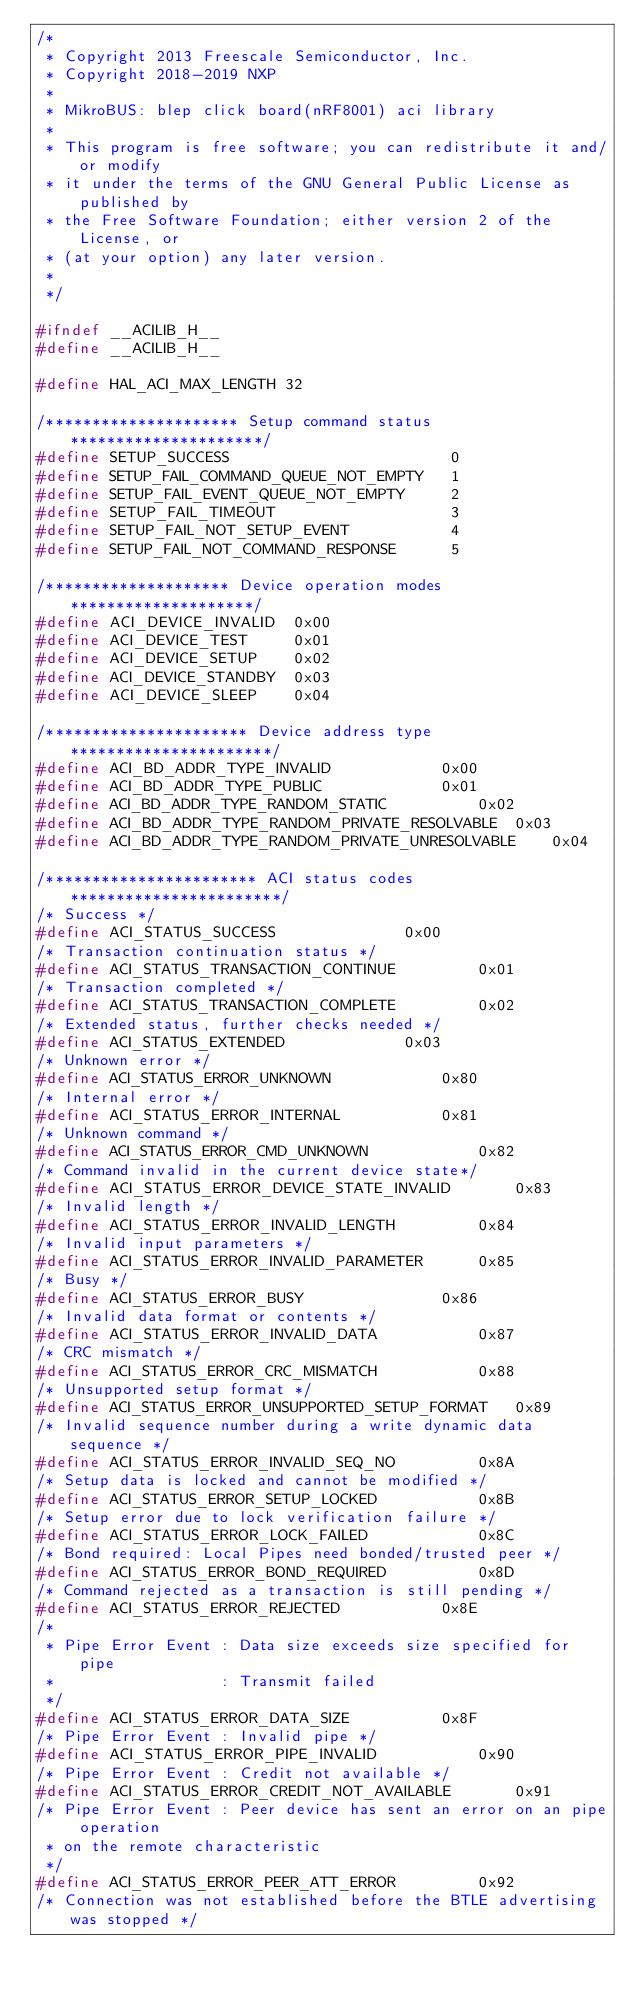Convert code to text. <code><loc_0><loc_0><loc_500><loc_500><_C_>/*
 * Copyright 2013 Freescale Semiconductor, Inc.
 * Copyright 2018-2019 NXP
 *
 * MikroBUS: blep click board(nRF8001) aci library
 *
 * This program is free software; you can redistribute it and/or modify
 * it under the terms of the GNU General Public License as published by
 * the Free Software Foundation; either version 2 of the License, or
 * (at your option) any later version.
 *
 */

#ifndef __ACILIB_H__
#define __ACILIB_H__

#define HAL_ACI_MAX_LENGTH 32

/********************* Setup command status *********************/
#define SETUP_SUCCESS                        0
#define SETUP_FAIL_COMMAND_QUEUE_NOT_EMPTY   1
#define SETUP_FAIL_EVENT_QUEUE_NOT_EMPTY     2
#define SETUP_FAIL_TIMEOUT                   3
#define SETUP_FAIL_NOT_SETUP_EVENT           4
#define SETUP_FAIL_NOT_COMMAND_RESPONSE      5

/******************** Device operation modes ********************/
#define ACI_DEVICE_INVALID	0x00
#define ACI_DEVICE_TEST		0x01
#define ACI_DEVICE_SETUP	0x02
#define ACI_DEVICE_STANDBY	0x03
#define ACI_DEVICE_SLEEP	0x04

/********************** Device address type **********************/
#define ACI_BD_ADDR_TYPE_INVALID			0x00
#define ACI_BD_ADDR_TYPE_PUBLIC				0x01
#define ACI_BD_ADDR_TYPE_RANDOM_STATIC			0x02
#define ACI_BD_ADDR_TYPE_RANDOM_PRIVATE_RESOLVABLE	0x03
#define ACI_BD_ADDR_TYPE_RANDOM_PRIVATE_UNRESOLVABLE	0x04

/*********************** ACI status codes ***********************/
/* Success */
#define ACI_STATUS_SUCCESS				0x00
/* Transaction continuation status */
#define ACI_STATUS_TRANSACTION_CONTINUE			0x01
/* Transaction completed */
#define ACI_STATUS_TRANSACTION_COMPLETE			0x02
/* Extended status, further checks needed */
#define ACI_STATUS_EXTENDED				0x03
/* Unknown error */
#define ACI_STATUS_ERROR_UNKNOWN			0x80
/* Internal error */
#define ACI_STATUS_ERROR_INTERNAL			0x81
/* Unknown command */
#define ACI_STATUS_ERROR_CMD_UNKNOWN			0x82
/* Command invalid in the current device state*/
#define ACI_STATUS_ERROR_DEVICE_STATE_INVALID		0x83
/* Invalid length */
#define ACI_STATUS_ERROR_INVALID_LENGTH			0x84
/* Invalid input parameters */
#define ACI_STATUS_ERROR_INVALID_PARAMETER		0x85
/* Busy */
#define ACI_STATUS_ERROR_BUSY				0x86
/* Invalid data format or contents */
#define ACI_STATUS_ERROR_INVALID_DATA			0x87
/* CRC mismatch */
#define ACI_STATUS_ERROR_CRC_MISMATCH			0x88
/* Unsupported setup format */
#define ACI_STATUS_ERROR_UNSUPPORTED_SETUP_FORMAT	0x89
/* Invalid sequence number during a write dynamic data sequence */
#define ACI_STATUS_ERROR_INVALID_SEQ_NO			0x8A
/* Setup data is locked and cannot be modified */
#define ACI_STATUS_ERROR_SETUP_LOCKED			0x8B
/* Setup error due to lock verification failure */
#define ACI_STATUS_ERROR_LOCK_FAILED			0x8C
/* Bond required: Local Pipes need bonded/trusted peer */
#define ACI_STATUS_ERROR_BOND_REQUIRED			0x8D
/* Command rejected as a transaction is still pending */
#define ACI_STATUS_ERROR_REJECTED			0x8E
/*
 * Pipe Error Event : Data size exceeds size specified for pipe
 *                  : Transmit failed
 */
#define ACI_STATUS_ERROR_DATA_SIZE			0x8F
/* Pipe Error Event : Invalid pipe */
#define ACI_STATUS_ERROR_PIPE_INVALID			0x90
/* Pipe Error Event : Credit not available */
#define ACI_STATUS_ERROR_CREDIT_NOT_AVAILABLE		0x91
/* Pipe Error Event : Peer device has sent an error on an pipe operation
 * on the remote characteristic
 */
#define ACI_STATUS_ERROR_PEER_ATT_ERROR			0x92
/* Connection was not established before the BTLE advertising was stopped */</code> 